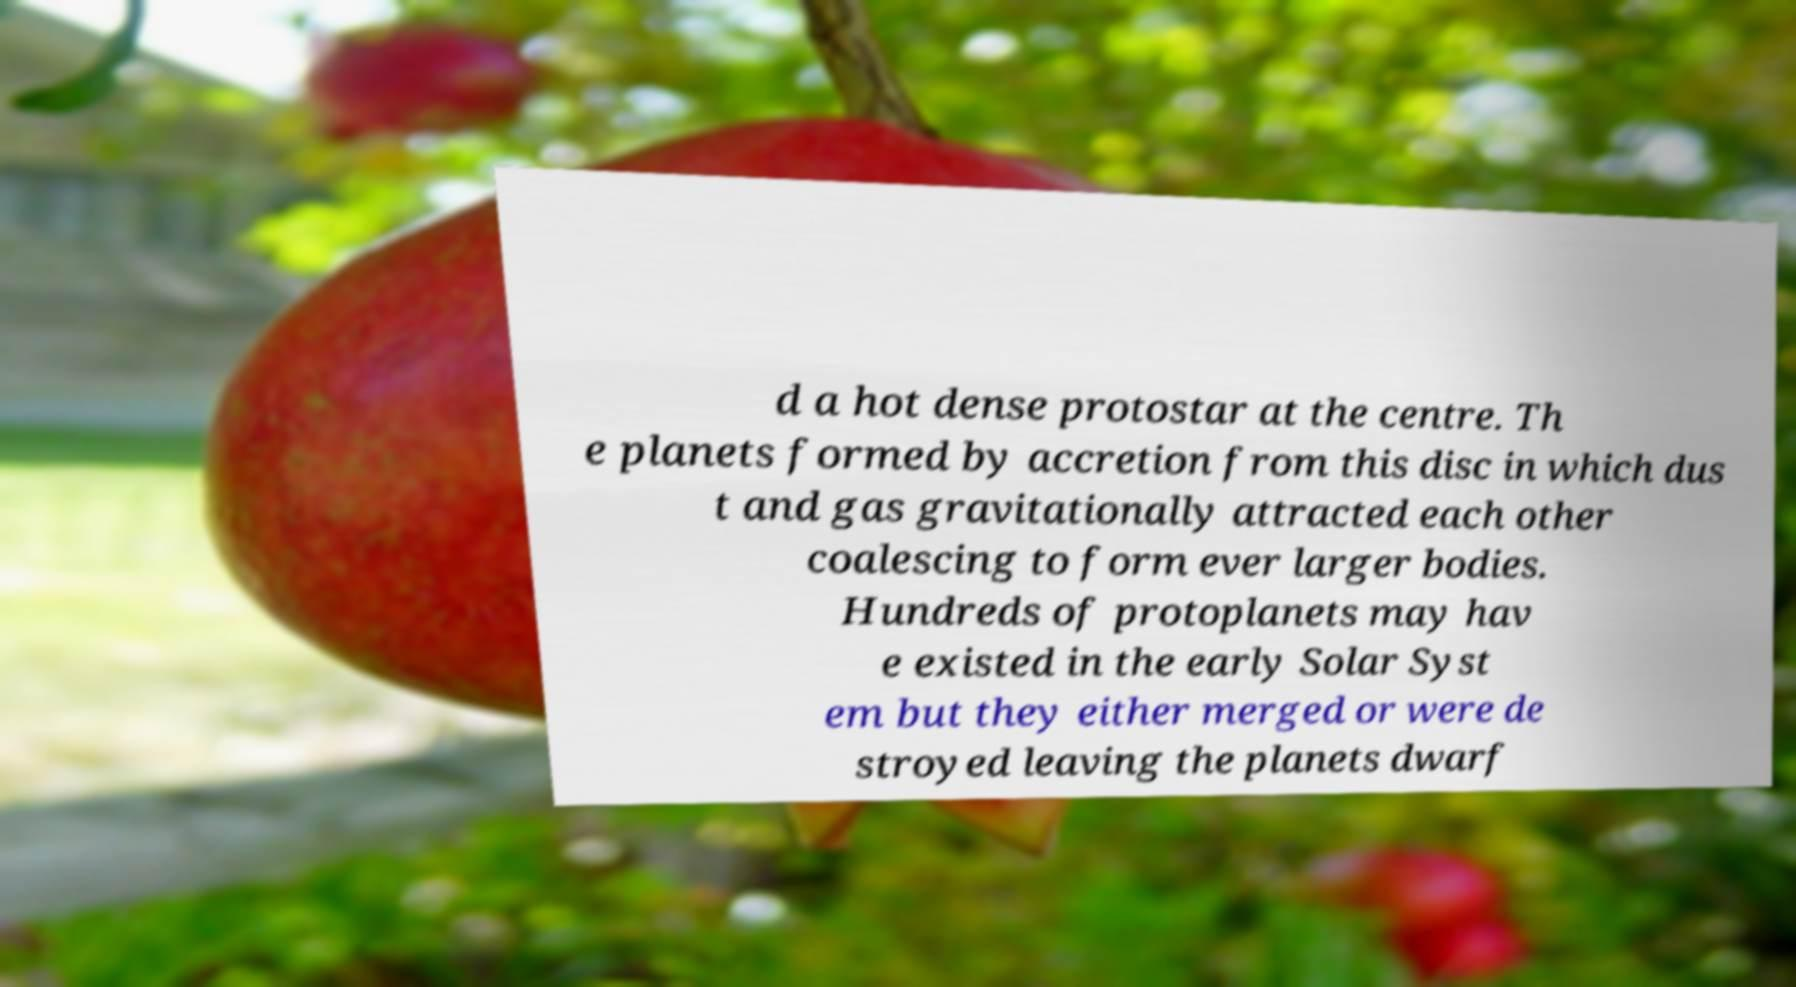Could you extract and type out the text from this image? d a hot dense protostar at the centre. Th e planets formed by accretion from this disc in which dus t and gas gravitationally attracted each other coalescing to form ever larger bodies. Hundreds of protoplanets may hav e existed in the early Solar Syst em but they either merged or were de stroyed leaving the planets dwarf 